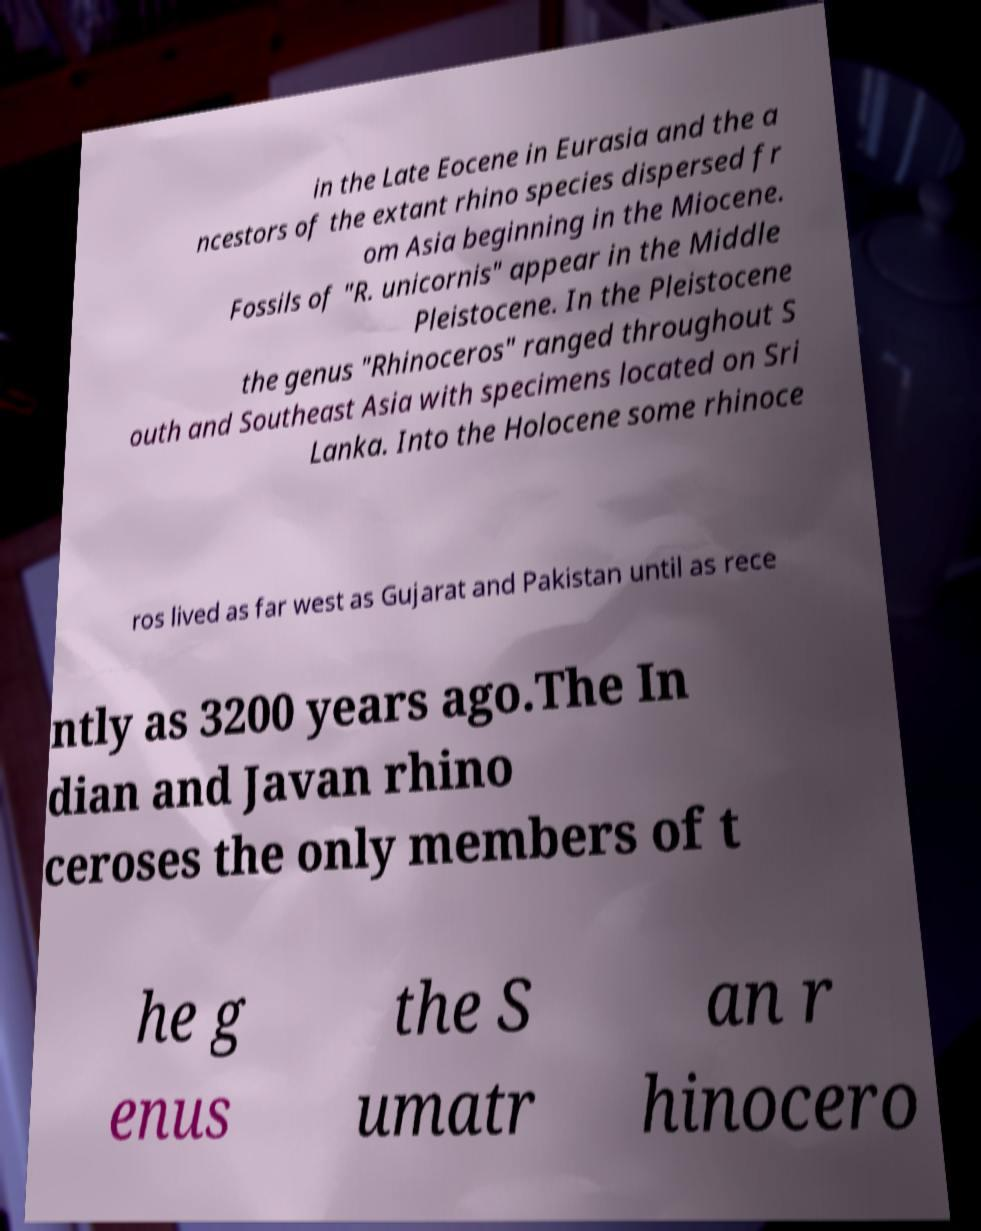Please identify and transcribe the text found in this image. in the Late Eocene in Eurasia and the a ncestors of the extant rhino species dispersed fr om Asia beginning in the Miocene. Fossils of "R. unicornis" appear in the Middle Pleistocene. In the Pleistocene the genus "Rhinoceros" ranged throughout S outh and Southeast Asia with specimens located on Sri Lanka. Into the Holocene some rhinoce ros lived as far west as Gujarat and Pakistan until as rece ntly as 3200 years ago.The In dian and Javan rhino ceroses the only members of t he g enus the S umatr an r hinocero 